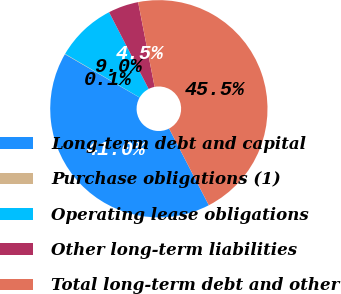<chart> <loc_0><loc_0><loc_500><loc_500><pie_chart><fcel>Long-term debt and capital<fcel>Purchase obligations (1)<fcel>Operating lease obligations<fcel>Other long-term liabilities<fcel>Total long-term debt and other<nl><fcel>40.98%<fcel>0.06%<fcel>8.99%<fcel>4.52%<fcel>45.45%<nl></chart> 